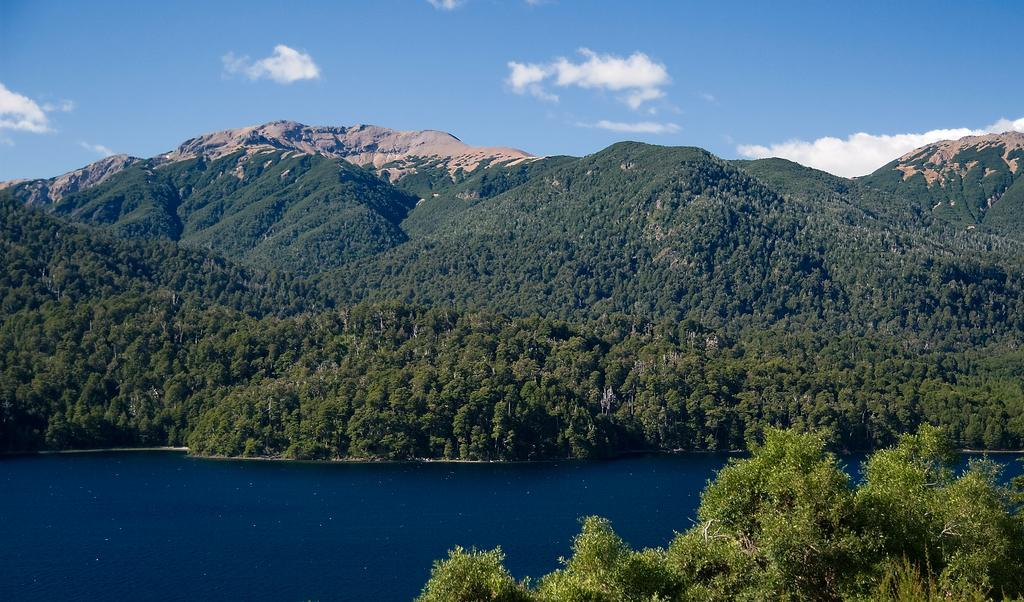What type of landscape is shown in the image? There is a hill view in the image. What can be seen at the top of the image? The sky is visible at the top of the image. What type of vegetation is present at the bottom of the image? There are bushes at the bottom of the image. What body of water is visible at the bottom of the image? There is a lake visible at the bottom of the image. What type of dinner is being served in the image? There is no dinner or food visible in the image; it features a hill view with a lake and bushes. What kind of experience can be gained from the image? The image itself does not offer an experience, but it may evoke feelings of tranquility or inspire a desire to visit a similar location. 